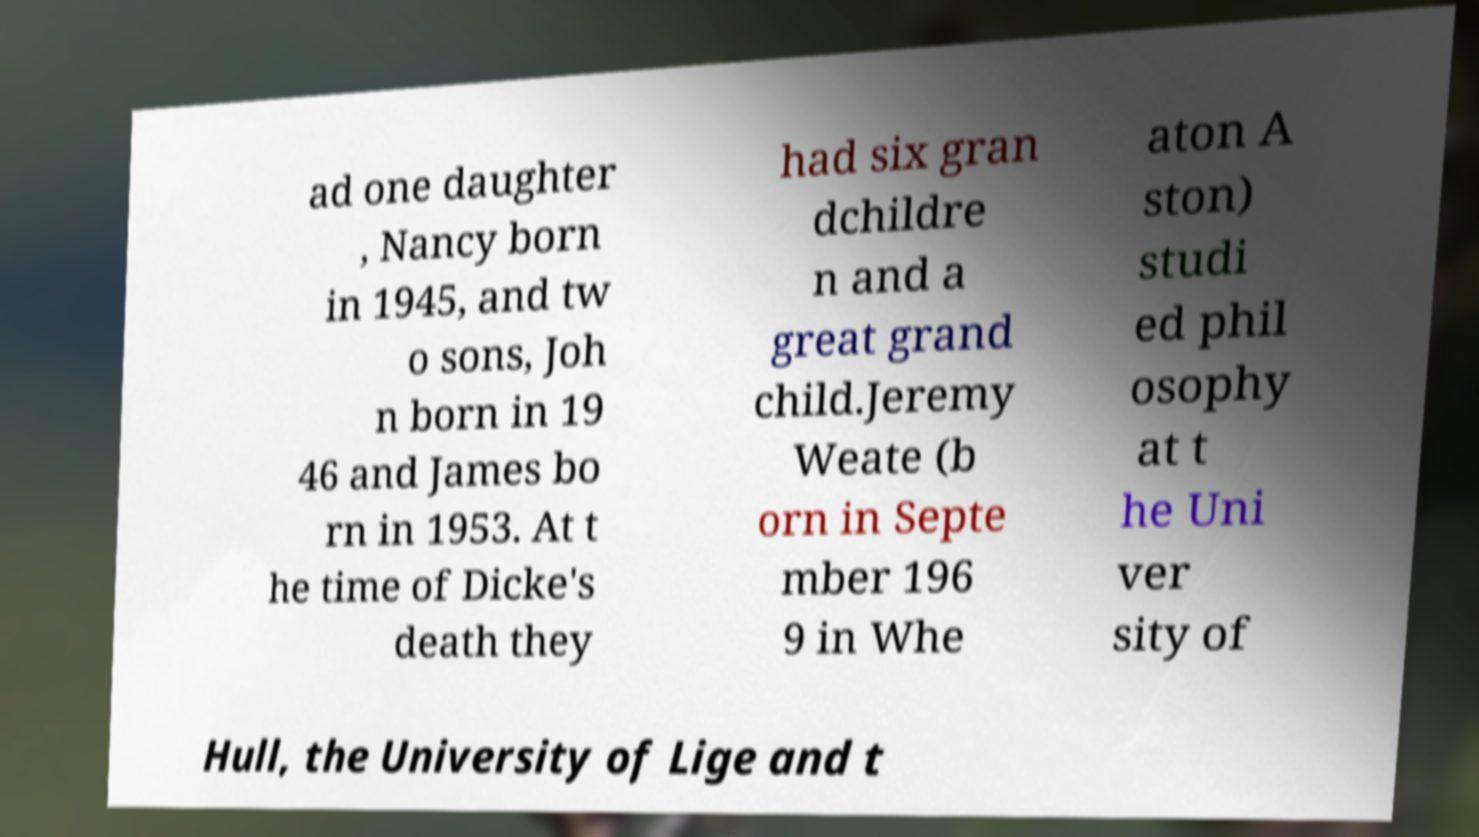Could you extract and type out the text from this image? ad one daughter , Nancy born in 1945, and tw o sons, Joh n born in 19 46 and James bo rn in 1953. At t he time of Dicke's death they had six gran dchildre n and a great grand child.Jeremy Weate (b orn in Septe mber 196 9 in Whe aton A ston) studi ed phil osophy at t he Uni ver sity of Hull, the University of Lige and t 